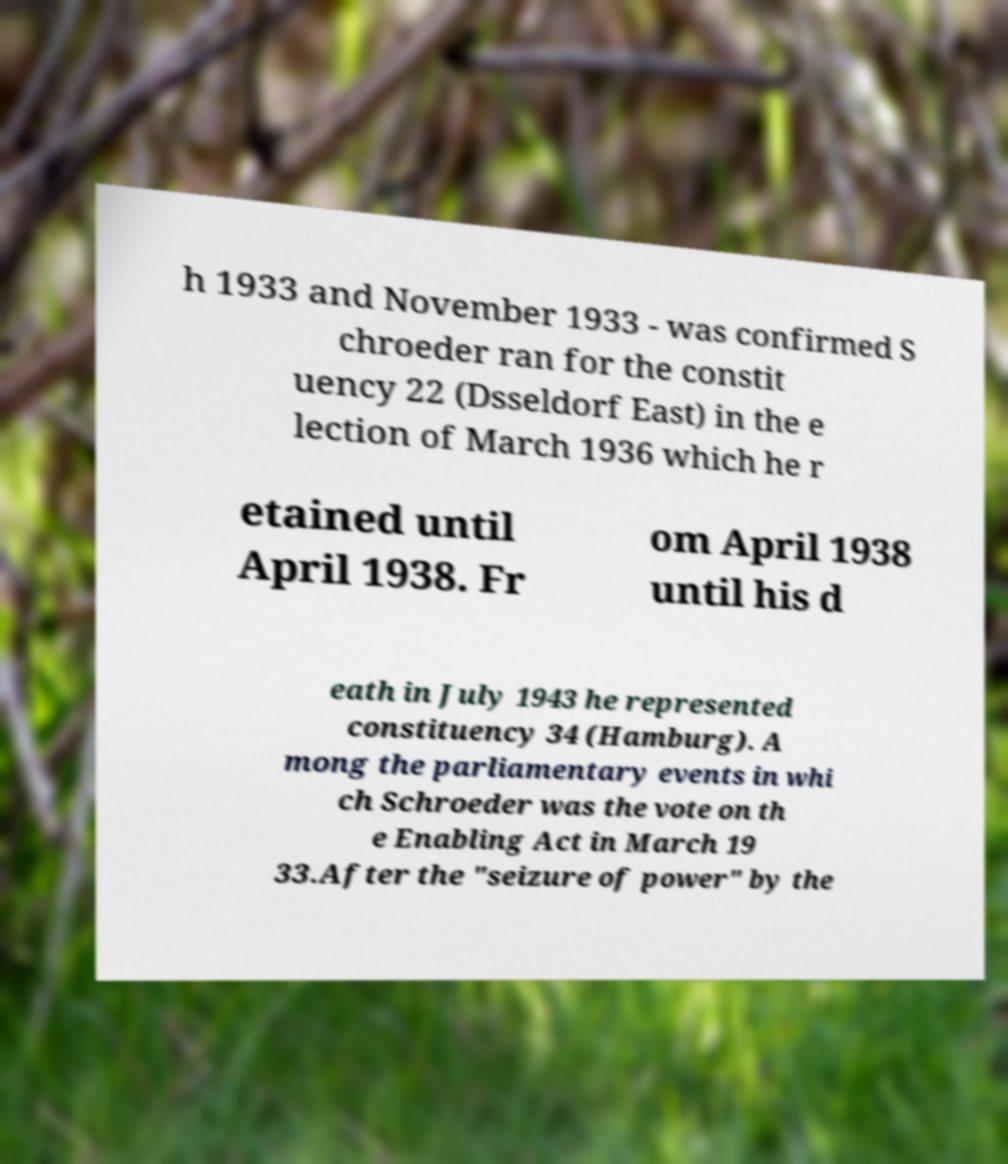Could you assist in decoding the text presented in this image and type it out clearly? h 1933 and November 1933 - was confirmed S chroeder ran for the constit uency 22 (Dsseldorf East) in the e lection of March 1936 which he r etained until April 1938. Fr om April 1938 until his d eath in July 1943 he represented constituency 34 (Hamburg). A mong the parliamentary events in whi ch Schroeder was the vote on th e Enabling Act in March 19 33.After the "seizure of power" by the 